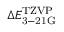<formula> <loc_0><loc_0><loc_500><loc_500>\Delta E _ { 3 - 2 1 G } ^ { T Z V P }</formula> 